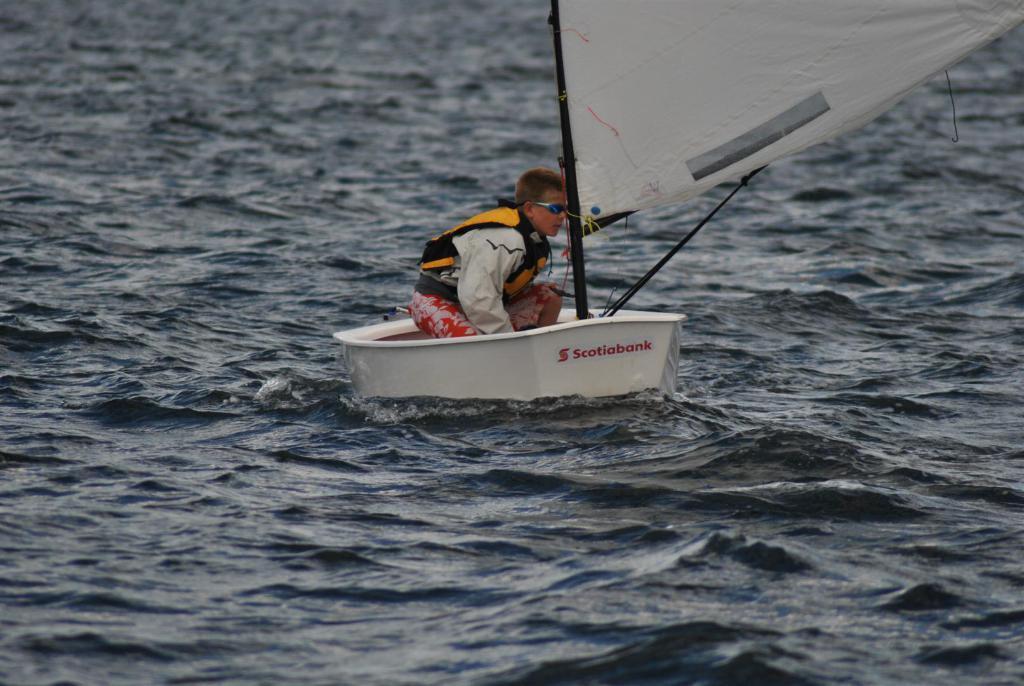Could you give a brief overview of what you see in this image? In this picture we can observe a boy sitting in a small white color boat. He is wearing life jacket and spectacles. We can observe a white color sailing cloth. The boat is on the water. In the background there is an ocean. 